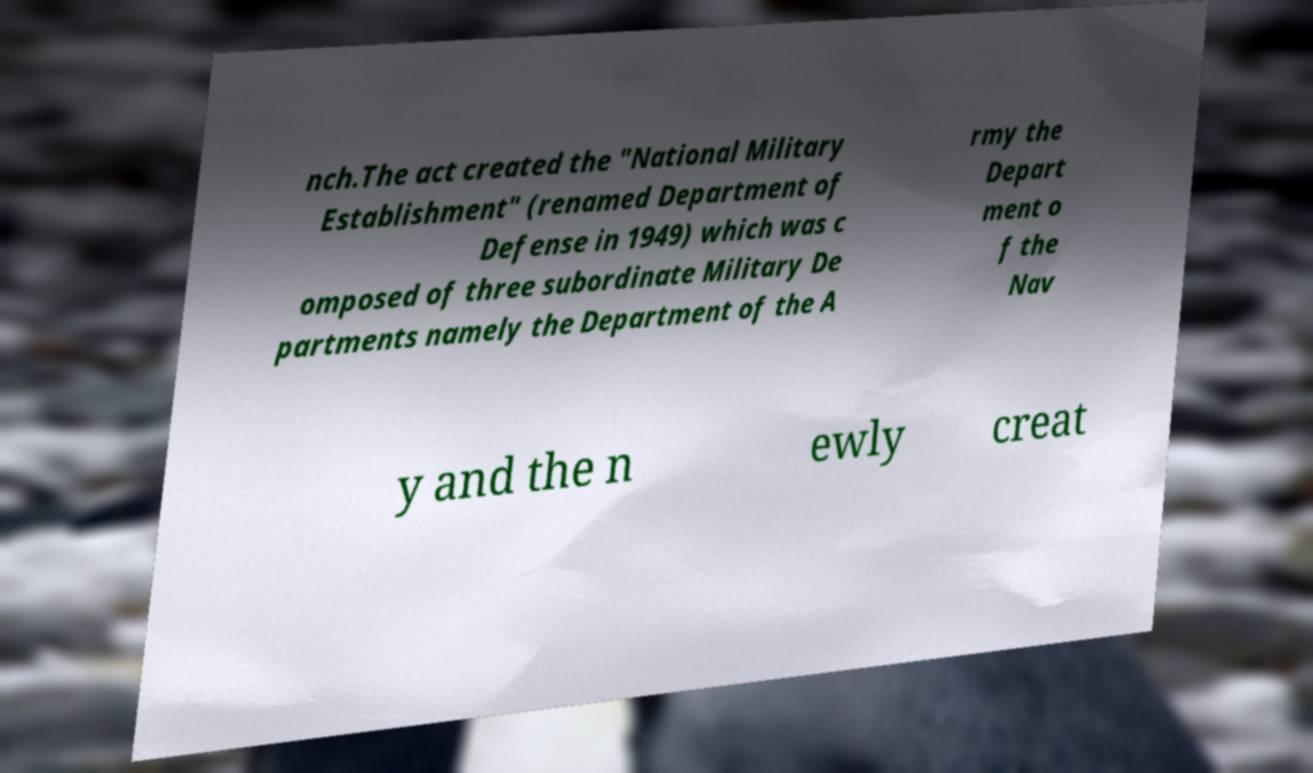What messages or text are displayed in this image? I need them in a readable, typed format. nch.The act created the "National Military Establishment" (renamed Department of Defense in 1949) which was c omposed of three subordinate Military De partments namely the Department of the A rmy the Depart ment o f the Nav y and the n ewly creat 